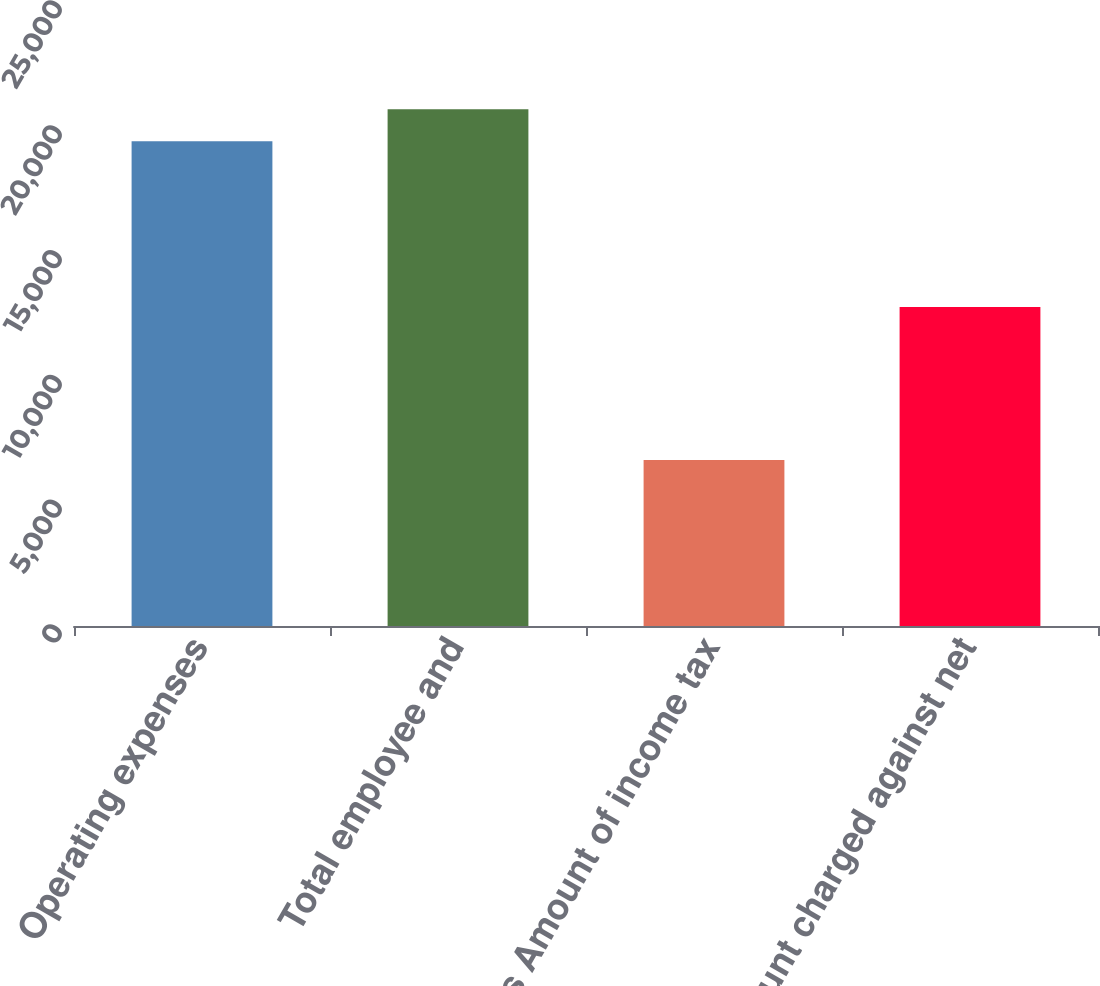<chart> <loc_0><loc_0><loc_500><loc_500><bar_chart><fcel>Operating expenses<fcel>Total employee and<fcel>Less Amount of income tax<fcel>Amount charged against net<nl><fcel>19424<fcel>20701.8<fcel>6646<fcel>12778<nl></chart> 